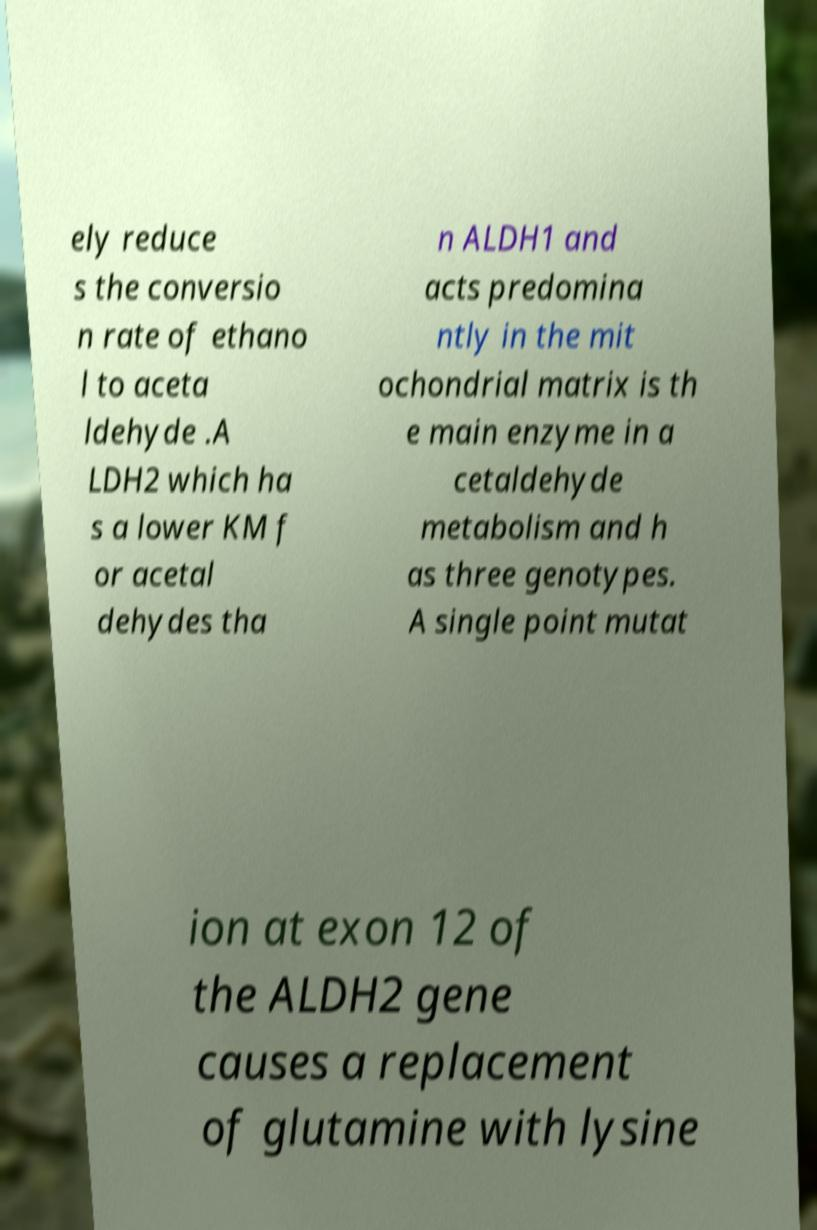There's text embedded in this image that I need extracted. Can you transcribe it verbatim? ely reduce s the conversio n rate of ethano l to aceta ldehyde .A LDH2 which ha s a lower KM f or acetal dehydes tha n ALDH1 and acts predomina ntly in the mit ochondrial matrix is th e main enzyme in a cetaldehyde metabolism and h as three genotypes. A single point mutat ion at exon 12 of the ALDH2 gene causes a replacement of glutamine with lysine 